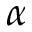<formula> <loc_0><loc_0><loc_500><loc_500>\alpha</formula> 